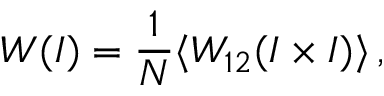Convert formula to latex. <formula><loc_0><loc_0><loc_500><loc_500>W ( I ) = \frac { 1 } { N } \langle W _ { 1 2 } ( I \times I ) \rangle \, ,</formula> 